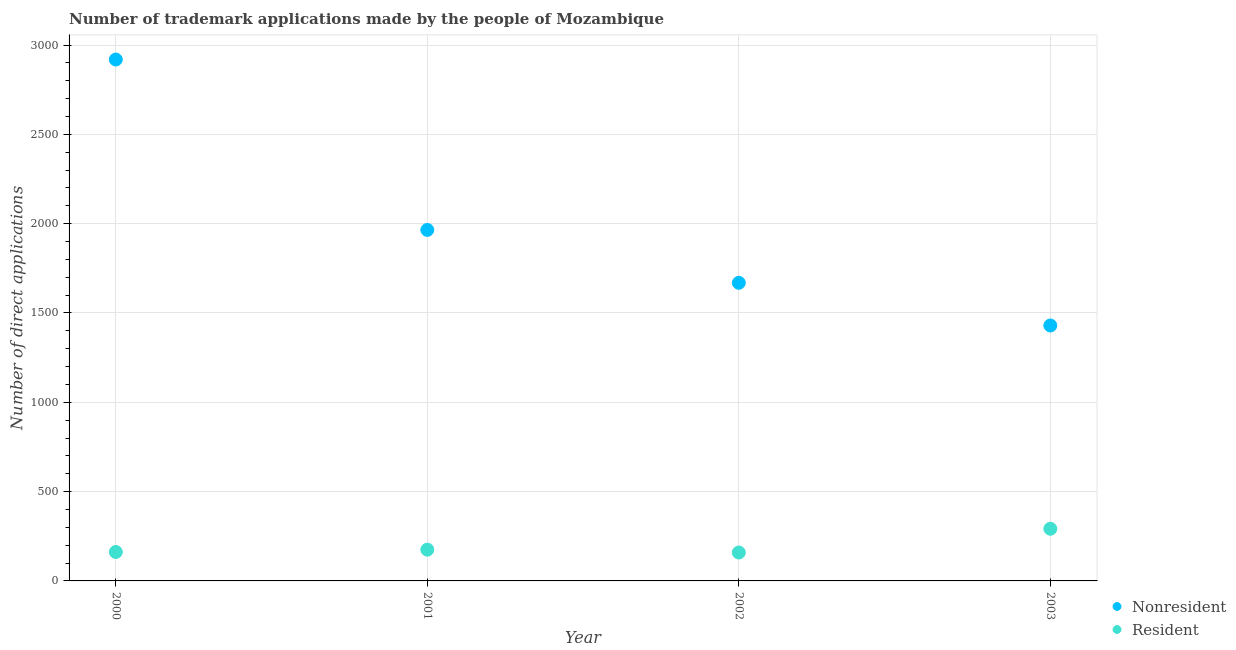Is the number of dotlines equal to the number of legend labels?
Make the answer very short. Yes. What is the number of trademark applications made by non residents in 2001?
Offer a terse response. 1965. Across all years, what is the maximum number of trademark applications made by residents?
Your answer should be very brief. 292. Across all years, what is the minimum number of trademark applications made by non residents?
Your response must be concise. 1430. In which year was the number of trademark applications made by residents minimum?
Ensure brevity in your answer.  2002. What is the total number of trademark applications made by non residents in the graph?
Ensure brevity in your answer.  7983. What is the difference between the number of trademark applications made by non residents in 2002 and that in 2003?
Give a very brief answer. 239. What is the difference between the number of trademark applications made by non residents in 2002 and the number of trademark applications made by residents in 2000?
Ensure brevity in your answer.  1507. What is the average number of trademark applications made by residents per year?
Make the answer very short. 197. In the year 2001, what is the difference between the number of trademark applications made by non residents and number of trademark applications made by residents?
Keep it short and to the point. 1790. What is the ratio of the number of trademark applications made by non residents in 2001 to that in 2003?
Keep it short and to the point. 1.37. Is the number of trademark applications made by non residents in 2000 less than that in 2002?
Your response must be concise. No. What is the difference between the highest and the second highest number of trademark applications made by residents?
Offer a very short reply. 117. What is the difference between the highest and the lowest number of trademark applications made by non residents?
Offer a very short reply. 1489. In how many years, is the number of trademark applications made by residents greater than the average number of trademark applications made by residents taken over all years?
Your answer should be compact. 1. Is the number of trademark applications made by residents strictly greater than the number of trademark applications made by non residents over the years?
Provide a succinct answer. No. Is the number of trademark applications made by residents strictly less than the number of trademark applications made by non residents over the years?
Give a very brief answer. Yes. Are the values on the major ticks of Y-axis written in scientific E-notation?
Your response must be concise. No. Does the graph contain grids?
Give a very brief answer. Yes. How many legend labels are there?
Offer a terse response. 2. How are the legend labels stacked?
Give a very brief answer. Vertical. What is the title of the graph?
Your answer should be very brief. Number of trademark applications made by the people of Mozambique. What is the label or title of the X-axis?
Offer a terse response. Year. What is the label or title of the Y-axis?
Keep it short and to the point. Number of direct applications. What is the Number of direct applications of Nonresident in 2000?
Your answer should be compact. 2919. What is the Number of direct applications of Resident in 2000?
Offer a terse response. 162. What is the Number of direct applications of Nonresident in 2001?
Make the answer very short. 1965. What is the Number of direct applications in Resident in 2001?
Give a very brief answer. 175. What is the Number of direct applications of Nonresident in 2002?
Give a very brief answer. 1669. What is the Number of direct applications in Resident in 2002?
Offer a terse response. 159. What is the Number of direct applications in Nonresident in 2003?
Give a very brief answer. 1430. What is the Number of direct applications in Resident in 2003?
Keep it short and to the point. 292. Across all years, what is the maximum Number of direct applications of Nonresident?
Your answer should be compact. 2919. Across all years, what is the maximum Number of direct applications of Resident?
Your answer should be very brief. 292. Across all years, what is the minimum Number of direct applications in Nonresident?
Keep it short and to the point. 1430. Across all years, what is the minimum Number of direct applications of Resident?
Your response must be concise. 159. What is the total Number of direct applications of Nonresident in the graph?
Ensure brevity in your answer.  7983. What is the total Number of direct applications in Resident in the graph?
Provide a short and direct response. 788. What is the difference between the Number of direct applications in Nonresident in 2000 and that in 2001?
Give a very brief answer. 954. What is the difference between the Number of direct applications in Nonresident in 2000 and that in 2002?
Keep it short and to the point. 1250. What is the difference between the Number of direct applications in Resident in 2000 and that in 2002?
Give a very brief answer. 3. What is the difference between the Number of direct applications in Nonresident in 2000 and that in 2003?
Give a very brief answer. 1489. What is the difference between the Number of direct applications of Resident in 2000 and that in 2003?
Provide a succinct answer. -130. What is the difference between the Number of direct applications in Nonresident in 2001 and that in 2002?
Ensure brevity in your answer.  296. What is the difference between the Number of direct applications of Nonresident in 2001 and that in 2003?
Provide a succinct answer. 535. What is the difference between the Number of direct applications of Resident in 2001 and that in 2003?
Make the answer very short. -117. What is the difference between the Number of direct applications in Nonresident in 2002 and that in 2003?
Your answer should be compact. 239. What is the difference between the Number of direct applications in Resident in 2002 and that in 2003?
Your answer should be very brief. -133. What is the difference between the Number of direct applications of Nonresident in 2000 and the Number of direct applications of Resident in 2001?
Your answer should be very brief. 2744. What is the difference between the Number of direct applications in Nonresident in 2000 and the Number of direct applications in Resident in 2002?
Provide a succinct answer. 2760. What is the difference between the Number of direct applications of Nonresident in 2000 and the Number of direct applications of Resident in 2003?
Offer a very short reply. 2627. What is the difference between the Number of direct applications of Nonresident in 2001 and the Number of direct applications of Resident in 2002?
Your answer should be very brief. 1806. What is the difference between the Number of direct applications of Nonresident in 2001 and the Number of direct applications of Resident in 2003?
Your answer should be very brief. 1673. What is the difference between the Number of direct applications of Nonresident in 2002 and the Number of direct applications of Resident in 2003?
Offer a terse response. 1377. What is the average Number of direct applications of Nonresident per year?
Provide a succinct answer. 1995.75. What is the average Number of direct applications of Resident per year?
Offer a terse response. 197. In the year 2000, what is the difference between the Number of direct applications in Nonresident and Number of direct applications in Resident?
Provide a succinct answer. 2757. In the year 2001, what is the difference between the Number of direct applications in Nonresident and Number of direct applications in Resident?
Your answer should be very brief. 1790. In the year 2002, what is the difference between the Number of direct applications in Nonresident and Number of direct applications in Resident?
Your answer should be compact. 1510. In the year 2003, what is the difference between the Number of direct applications in Nonresident and Number of direct applications in Resident?
Offer a terse response. 1138. What is the ratio of the Number of direct applications in Nonresident in 2000 to that in 2001?
Give a very brief answer. 1.49. What is the ratio of the Number of direct applications of Resident in 2000 to that in 2001?
Offer a very short reply. 0.93. What is the ratio of the Number of direct applications in Nonresident in 2000 to that in 2002?
Give a very brief answer. 1.75. What is the ratio of the Number of direct applications in Resident in 2000 to that in 2002?
Provide a succinct answer. 1.02. What is the ratio of the Number of direct applications of Nonresident in 2000 to that in 2003?
Offer a terse response. 2.04. What is the ratio of the Number of direct applications in Resident in 2000 to that in 2003?
Keep it short and to the point. 0.55. What is the ratio of the Number of direct applications of Nonresident in 2001 to that in 2002?
Provide a succinct answer. 1.18. What is the ratio of the Number of direct applications of Resident in 2001 to that in 2002?
Offer a very short reply. 1.1. What is the ratio of the Number of direct applications of Nonresident in 2001 to that in 2003?
Offer a very short reply. 1.37. What is the ratio of the Number of direct applications of Resident in 2001 to that in 2003?
Provide a succinct answer. 0.6. What is the ratio of the Number of direct applications in Nonresident in 2002 to that in 2003?
Provide a short and direct response. 1.17. What is the ratio of the Number of direct applications of Resident in 2002 to that in 2003?
Provide a succinct answer. 0.54. What is the difference between the highest and the second highest Number of direct applications of Nonresident?
Give a very brief answer. 954. What is the difference between the highest and the second highest Number of direct applications of Resident?
Your answer should be compact. 117. What is the difference between the highest and the lowest Number of direct applications in Nonresident?
Make the answer very short. 1489. What is the difference between the highest and the lowest Number of direct applications of Resident?
Offer a terse response. 133. 